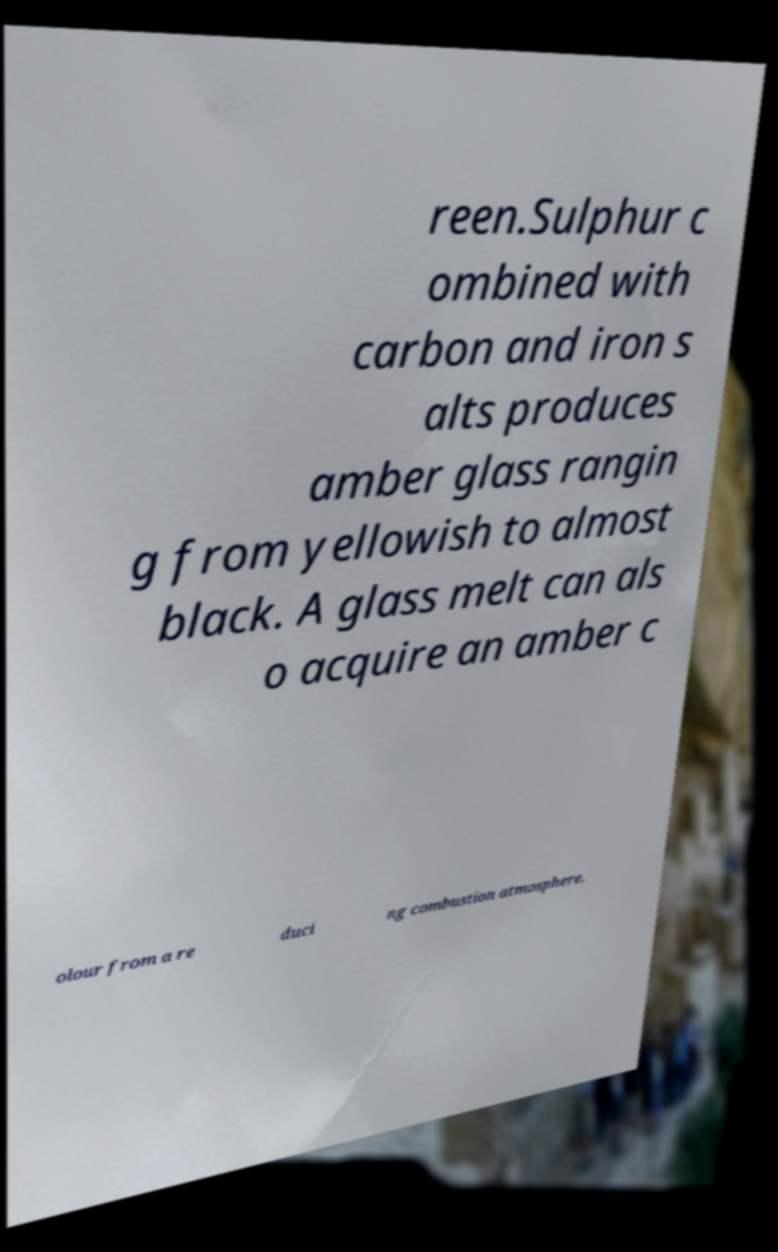Can you read and provide the text displayed in the image?This photo seems to have some interesting text. Can you extract and type it out for me? reen.Sulphur c ombined with carbon and iron s alts produces amber glass rangin g from yellowish to almost black. A glass melt can als o acquire an amber c olour from a re duci ng combustion atmosphere. 